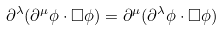Convert formula to latex. <formula><loc_0><loc_0><loc_500><loc_500>\partial ^ { \lambda } ( \partial ^ { \mu } \phi \cdot \square \phi ) = \partial ^ { \mu } ( \partial ^ { \lambda } \phi \cdot \square \phi )</formula> 